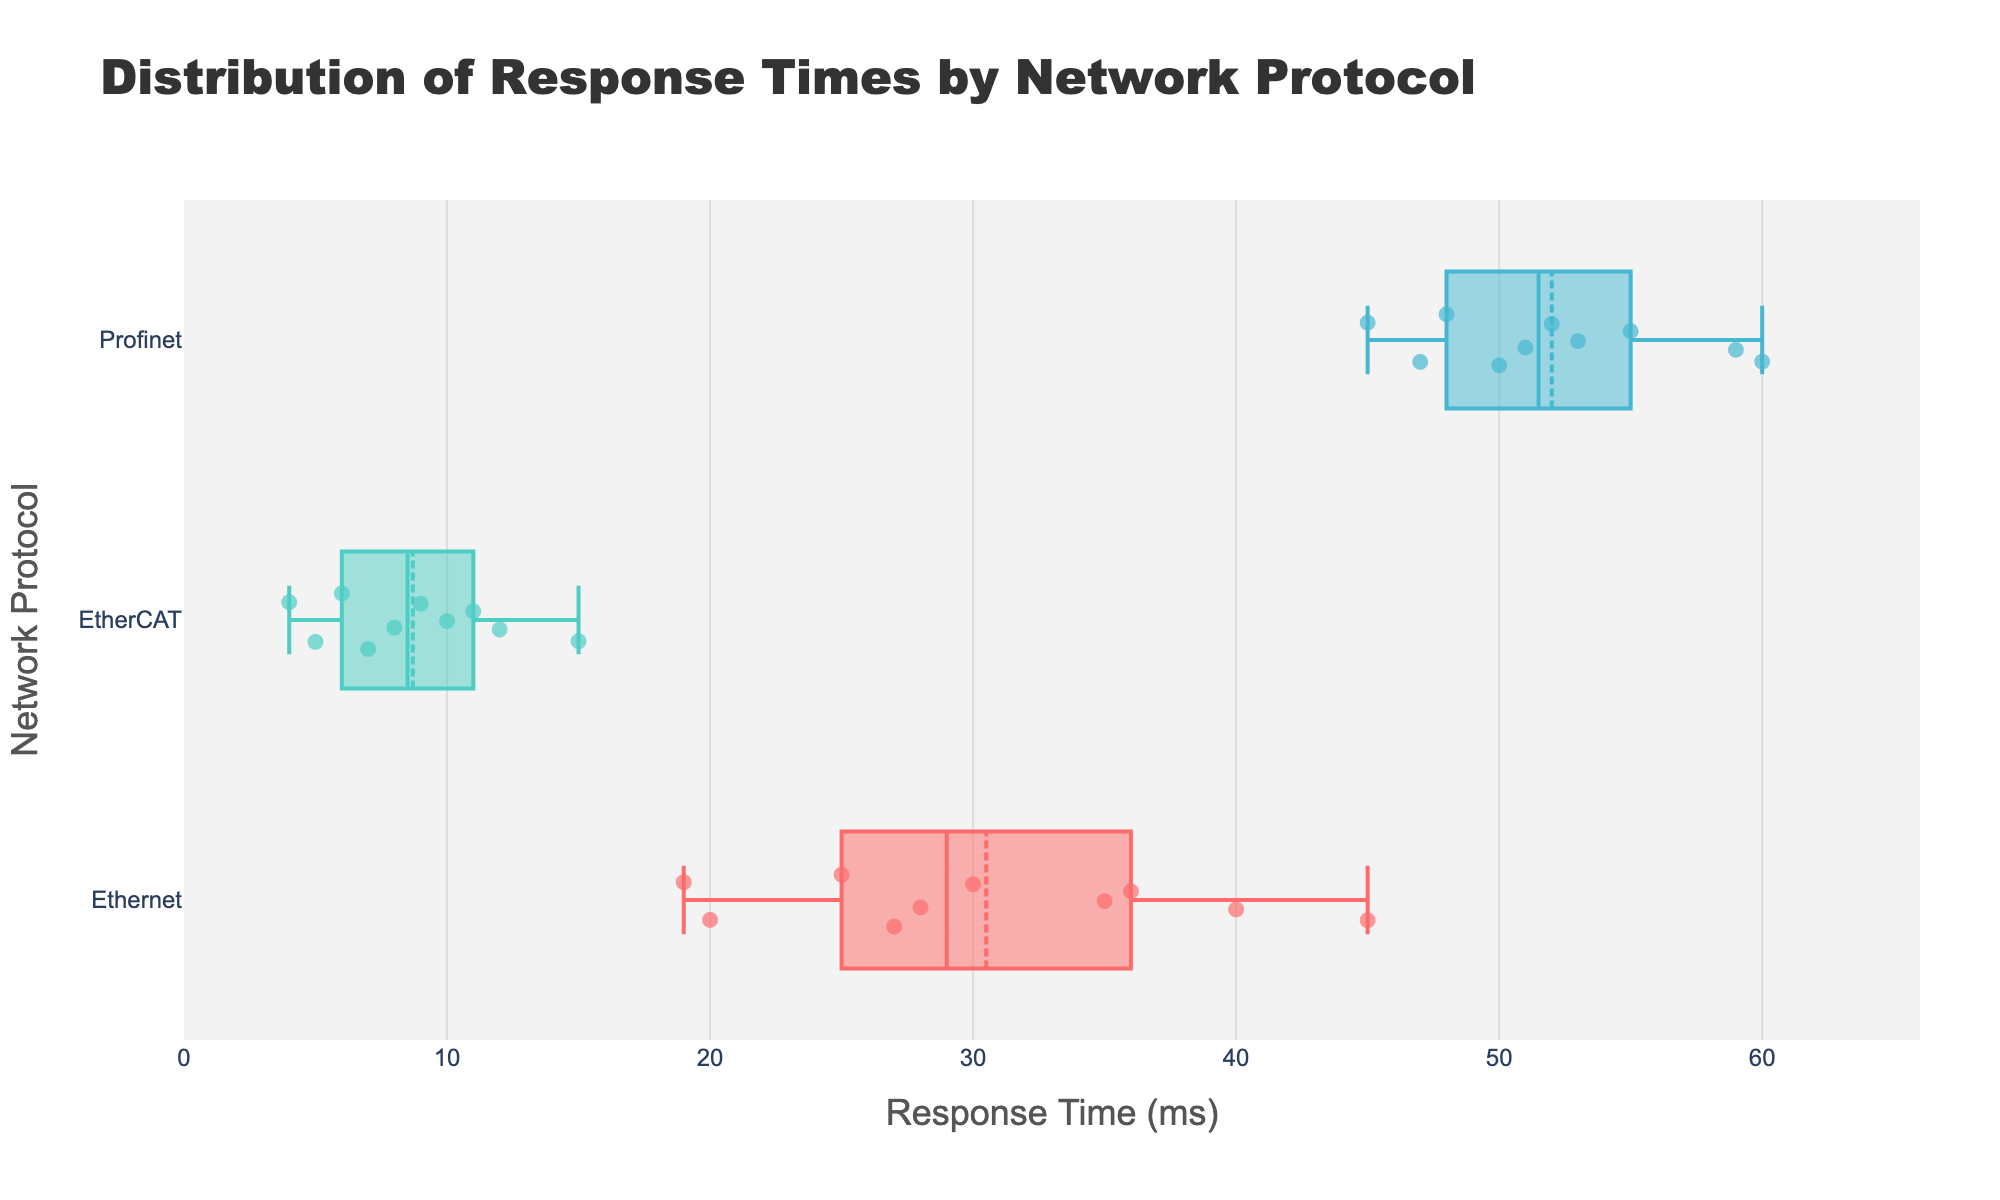What is the title of the plot? The title is usually located at the top of the figure. Here it is written in a larger font size and reads "Distribution of Response Times by Network Protocol".
Answer: Distribution of Response Times by Network Protocol What are the different network protocols shown in the plot? The plot has separate boxes for each category, represented by different protocols. They are Ethernet, EtherCAT, and Profinet.
Answer: Ethernet, EtherCAT, Profinet Which protocol has the lowest response time? By looking at the x-axis values and the position of the lower whisker of the Box plot, EtherCAT has the lowest response time around 4 ms.
Answer: EtherCAT What is the range of response times for Ethernet? The range is determined by the minimum and maximum values shown by the whiskers of the box plot for Ethernet, which are 19 ms and 45 ms respectively.
Answer: 19 ms to 45 ms Which protocol has the highest median response time? The median is represented by the line inside the box for each protocol. Profinet's median is the highest compared to Ethernet and EtherCAT.
Answer: Profinet How does the distribution of response times compare among the protocols? By observing the spread and central tendencies, EtherCAT has a much smaller and compact range compared to Ethernet and Profinet whose boxes and whiskers extend further.
Answer: EtherCAT < Ethernet < Profinet What protocol shows the most variability in response times? Variability is shown by the interquartile range (IQR) and the spread of the whiskers. Profinet's box and whiskers are the widest amongst all, indicating the highest variability.
Answer: Profinet What is the mean response time for EtherCAT? The box plot with mean markers shows the mean as a small symbol within the box. For EtherCAT, it is approximately 8 ms.
Answer: Approximately 8 ms For which protocol do outliers appear farthest from the central tendency? Outliers can be identified by the points that fall outside the whiskers. Ethernet has a data point at 45 ms, which is quite far from the median compared to others.
Answer: Ethernet Among the protocols, which has the smallest interquartile range (IQR)? IQR is the length of the box in the box plot. EtherCAT has the smallest box, indicating the smallest IQR.
Answer: EtherCAT 